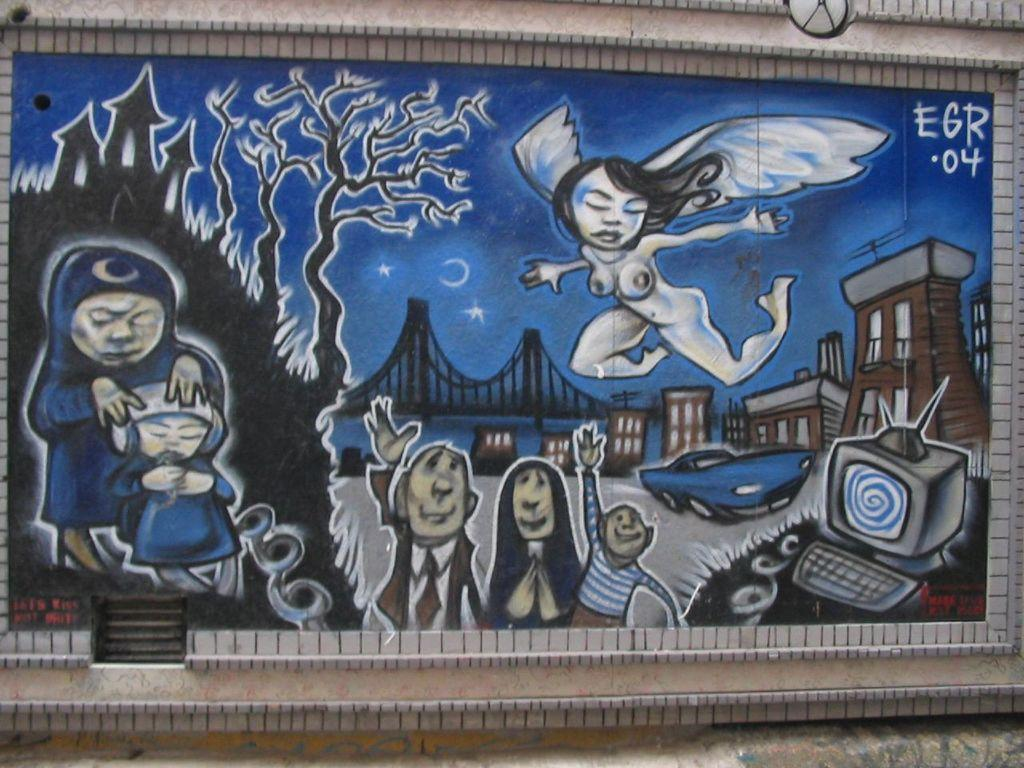What is the main object in the image? There is a frame in the image. What is inside the frame? The frame contains a painting. Where is the painting located? The painting is attached to a wall. What elements are depicted in the painting? The painting depicts persons, buildings, trees, and a car. What type of marble is used for the frame in the image? There is no mention of marble in the image or the provided facts, so we cannot determine the type of material used for the frame. Was the painting an afterthought in the design of the room? The provided facts do not give any information about the design process or the intention behind placing the painting on the wall, so we cannot determine if the painting was an afterthought. 